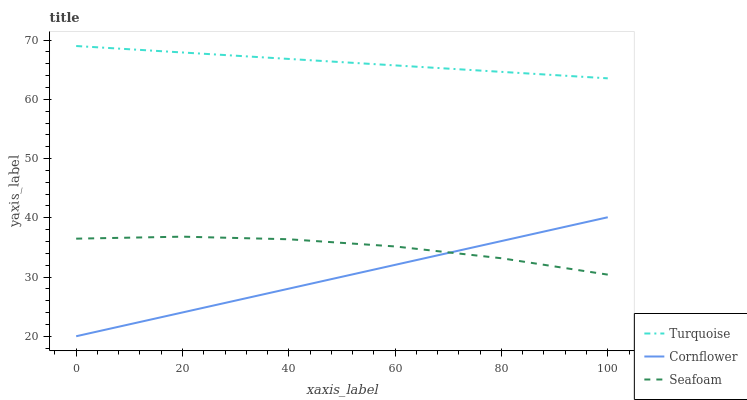Does Cornflower have the minimum area under the curve?
Answer yes or no. Yes. Does Turquoise have the maximum area under the curve?
Answer yes or no. Yes. Does Seafoam have the minimum area under the curve?
Answer yes or no. No. Does Seafoam have the maximum area under the curve?
Answer yes or no. No. Is Cornflower the smoothest?
Answer yes or no. Yes. Is Seafoam the roughest?
Answer yes or no. Yes. Is Turquoise the smoothest?
Answer yes or no. No. Is Turquoise the roughest?
Answer yes or no. No. Does Cornflower have the lowest value?
Answer yes or no. Yes. Does Seafoam have the lowest value?
Answer yes or no. No. Does Turquoise have the highest value?
Answer yes or no. Yes. Does Seafoam have the highest value?
Answer yes or no. No. Is Seafoam less than Turquoise?
Answer yes or no. Yes. Is Turquoise greater than Seafoam?
Answer yes or no. Yes. Does Cornflower intersect Seafoam?
Answer yes or no. Yes. Is Cornflower less than Seafoam?
Answer yes or no. No. Is Cornflower greater than Seafoam?
Answer yes or no. No. Does Seafoam intersect Turquoise?
Answer yes or no. No. 